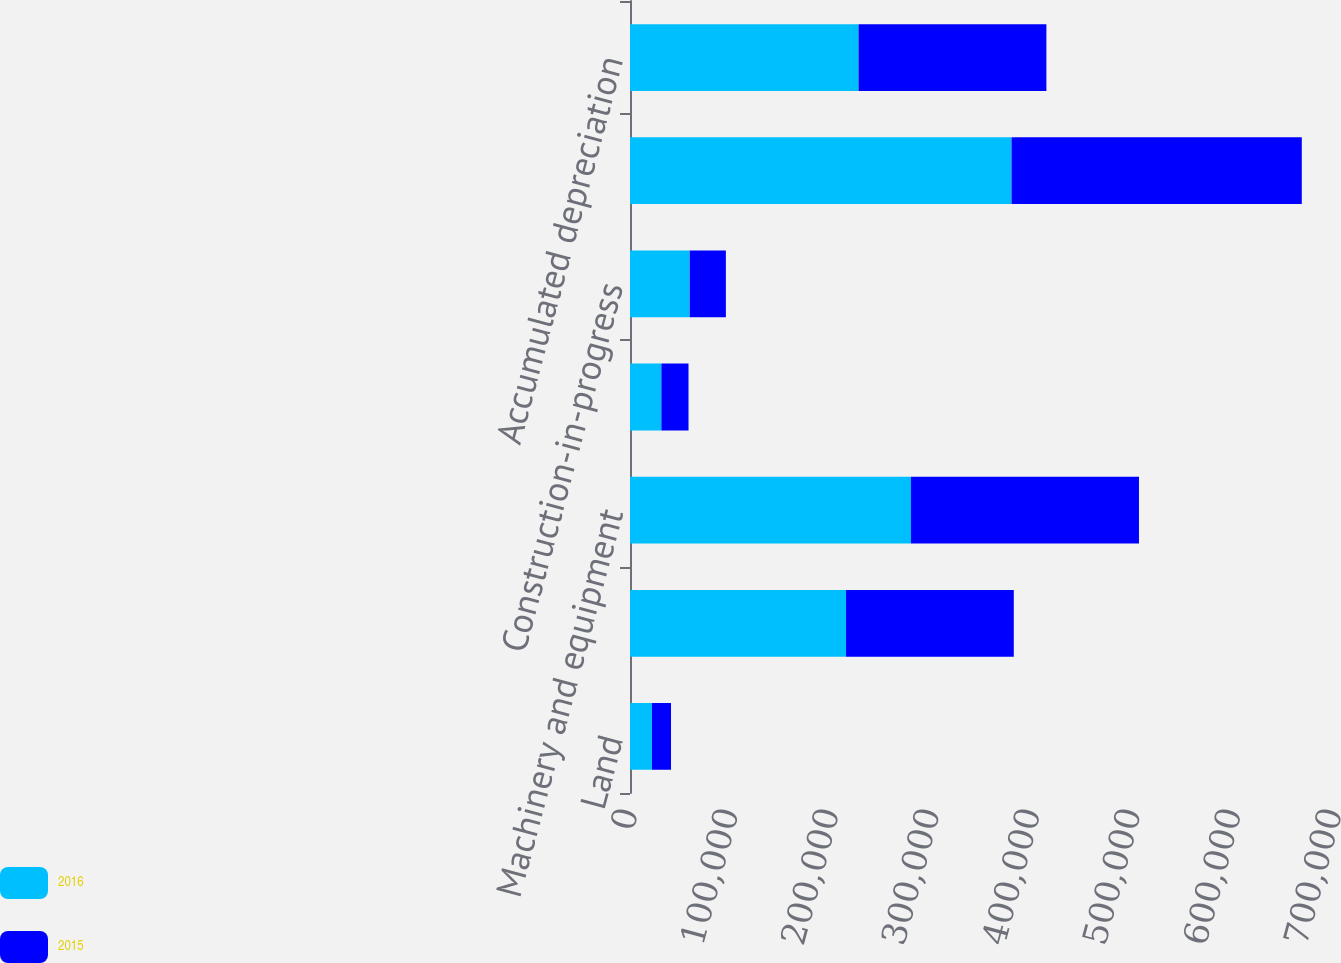Convert chart. <chart><loc_0><loc_0><loc_500><loc_500><stacked_bar_chart><ecel><fcel>Land<fcel>Buildings<fcel>Machinery and equipment<fcel>Office furniture and fixtures<fcel>Construction-in-progress<fcel>Total property plant and<fcel>Accumulated depreciation<nl><fcel>2016<fcel>21811<fcel>214830<fcel>279372<fcel>31210<fcel>59391<fcel>379375<fcel>227239<nl><fcel>2015<fcel>18962<fcel>166784<fcel>226724<fcel>26981<fcel>35946<fcel>288604<fcel>186793<nl></chart> 